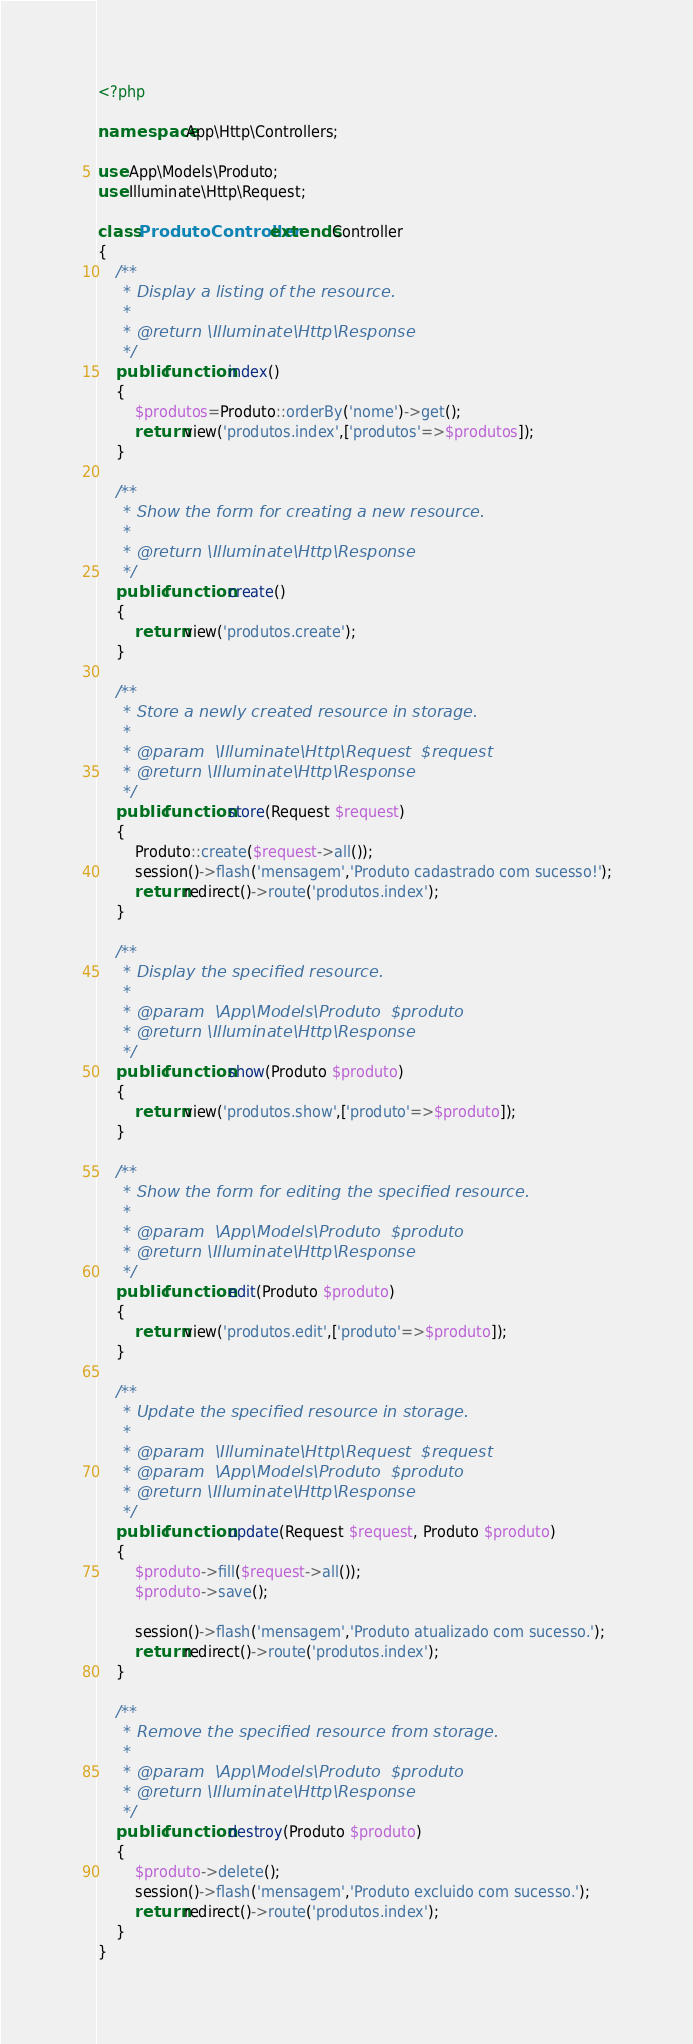Convert code to text. <code><loc_0><loc_0><loc_500><loc_500><_PHP_><?php

namespace App\Http\Controllers;

use App\Models\Produto;
use Illuminate\Http\Request;

class ProdutoController extends Controller
{
    /**
     * Display a listing of the resource.
     *
     * @return \Illuminate\Http\Response
     */
    public function index()
    {
        $produtos=Produto::orderBy('nome')->get();
        return view('produtos.index',['produtos'=>$produtos]);
    }

    /**
     * Show the form for creating a new resource.
     *
     * @return \Illuminate\Http\Response
     */
    public function create()
    {
        return view('produtos.create');
    }

    /**
     * Store a newly created resource in storage.
     *
     * @param  \Illuminate\Http\Request  $request
     * @return \Illuminate\Http\Response
     */
    public function store(Request $request)
    {
        Produto::create($request->all());
        session()->flash('mensagem','Produto cadastrado com sucesso!');
        return redirect()->route('produtos.index');
    }

    /**
     * Display the specified resource.
     *
     * @param  \App\Models\Produto  $produto
     * @return \Illuminate\Http\Response
     */
    public function show(Produto $produto)
    {
        return view('produtos.show',['produto'=>$produto]);
    }

    /**
     * Show the form for editing the specified resource.
     *
     * @param  \App\Models\Produto  $produto
     * @return \Illuminate\Http\Response
     */
    public function edit(Produto $produto)
    {
        return view('produtos.edit',['produto'=>$produto]);
    }

    /**
     * Update the specified resource in storage.
     *
     * @param  \Illuminate\Http\Request  $request
     * @param  \App\Models\Produto  $produto
     * @return \Illuminate\Http\Response
     */
    public function update(Request $request, Produto $produto)
    {
        $produto->fill($request->all());
        $produto->save();

        session()->flash('mensagem','Produto atualizado com sucesso.');
        return redirect()->route('produtos.index');
    }

    /**
     * Remove the specified resource from storage.
     *
     * @param  \App\Models\Produto  $produto
     * @return \Illuminate\Http\Response
     */
    public function destroy(Produto $produto)
    {
        $produto->delete();
        session()->flash('mensagem','Produto excluido com sucesso.');
        return redirect()->route('produtos.index');
    }
}</code> 